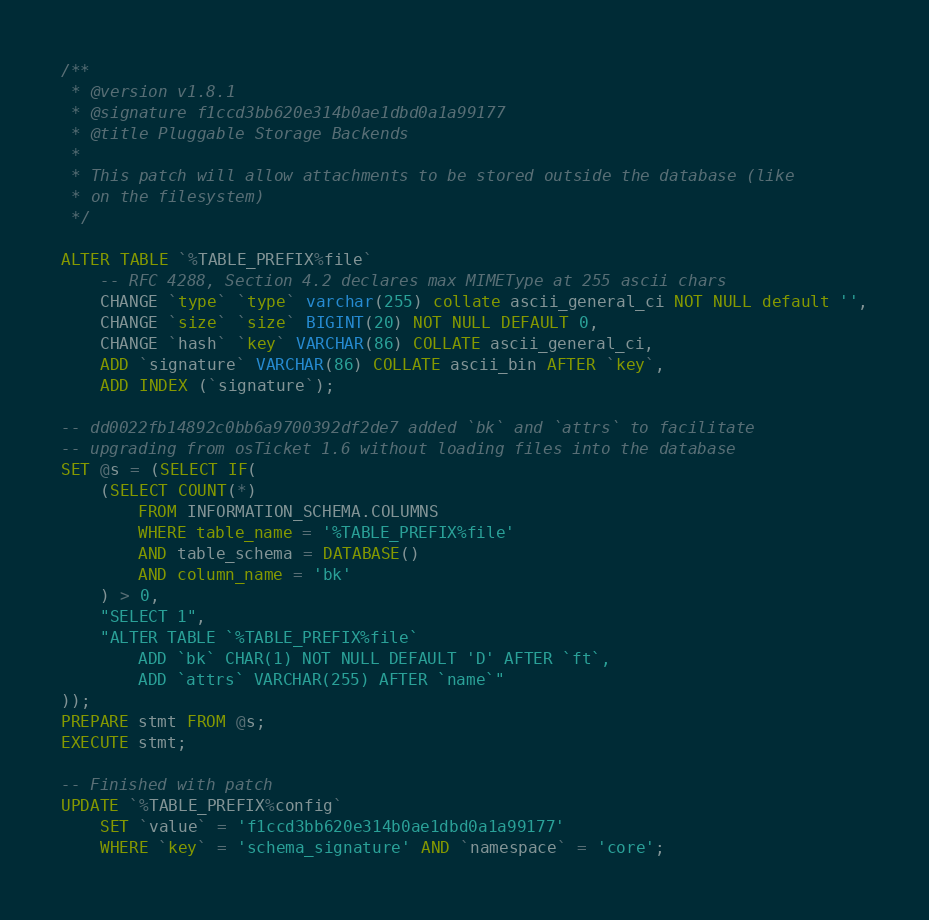<code> <loc_0><loc_0><loc_500><loc_500><_SQL_>/**
 * @version v1.8.1
 * @signature f1ccd3bb620e314b0ae1dbd0a1a99177
 * @title Pluggable Storage Backends
 *
 * This patch will allow attachments to be stored outside the database (like
 * on the filesystem)
 */

ALTER TABLE `%TABLE_PREFIX%file`
    -- RFC 4288, Section 4.2 declares max MIMEType at 255 ascii chars
    CHANGE `type` `type` varchar(255) collate ascii_general_ci NOT NULL default '',
    CHANGE `size` `size` BIGINT(20) NOT NULL DEFAULT 0,
    CHANGE `hash` `key` VARCHAR(86) COLLATE ascii_general_ci,
    ADD `signature` VARCHAR(86) COLLATE ascii_bin AFTER `key`,
    ADD INDEX (`signature`);

-- dd0022fb14892c0bb6a9700392df2de7 added `bk` and `attrs` to facilitate
-- upgrading from osTicket 1.6 without loading files into the database
SET @s = (SELECT IF(
    (SELECT COUNT(*)
        FROM INFORMATION_SCHEMA.COLUMNS
        WHERE table_name = '%TABLE_PREFIX%file'
        AND table_schema = DATABASE()
        AND column_name = 'bk'
    ) > 0,
    "SELECT 1",
    "ALTER TABLE `%TABLE_PREFIX%file`
        ADD `bk` CHAR(1) NOT NULL DEFAULT 'D' AFTER `ft`,
        ADD `attrs` VARCHAR(255) AFTER `name`"
));
PREPARE stmt FROM @s;
EXECUTE stmt;

-- Finished with patch
UPDATE `%TABLE_PREFIX%config`
    SET `value` = 'f1ccd3bb620e314b0ae1dbd0a1a99177'
    WHERE `key` = 'schema_signature' AND `namespace` = 'core';
</code> 